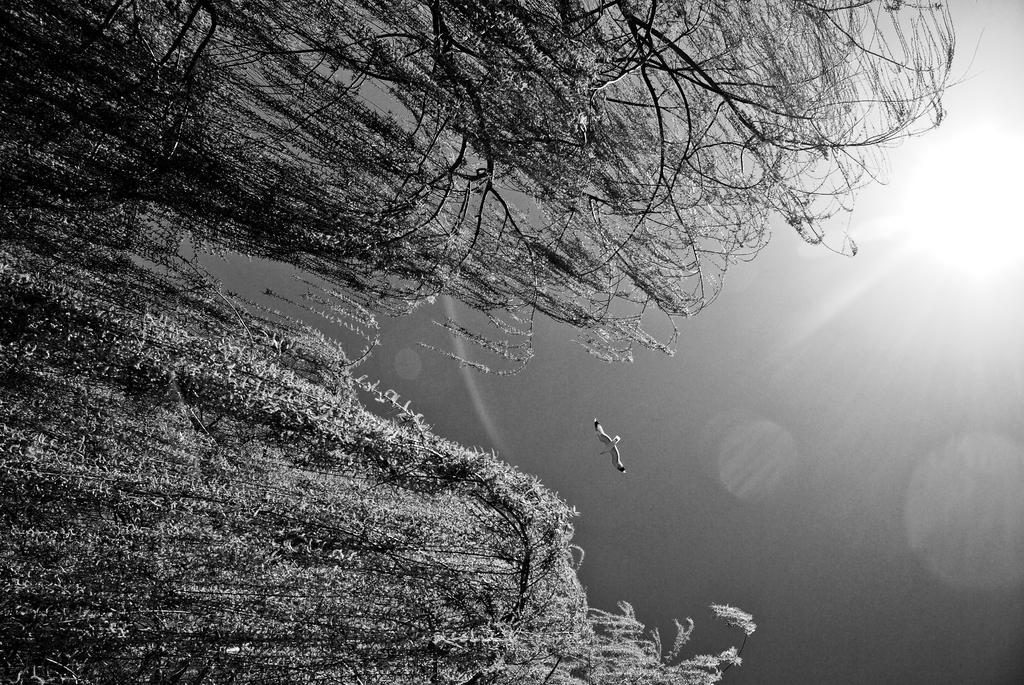Please provide a concise description of this image. In this image there are trees truncated towards the top of the image, there are trees truncated towards the left of the image, there are trees truncated towards the bottom of the image, there is a bird flying, there is the sun truncated towards the right of the image, at the background of the image there is the sky truncated. 